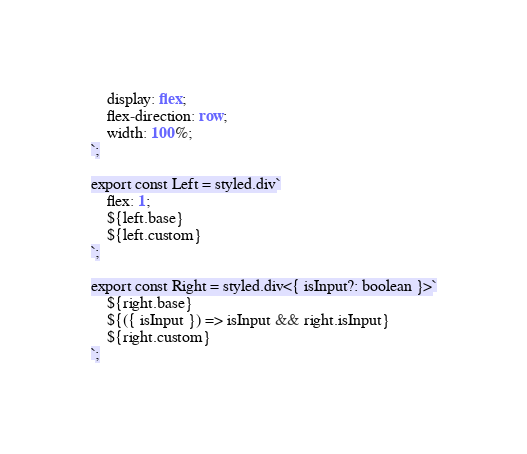<code> <loc_0><loc_0><loc_500><loc_500><_TypeScript_>    display: flex;
    flex-direction: row;
    width: 100%;
`;

export const Left = styled.div`
    flex: 1;
    ${left.base}
    ${left.custom}
`;

export const Right = styled.div<{ isInput?: boolean }>`
    ${right.base}
    ${({ isInput }) => isInput && right.isInput}
    ${right.custom}
`;
</code> 